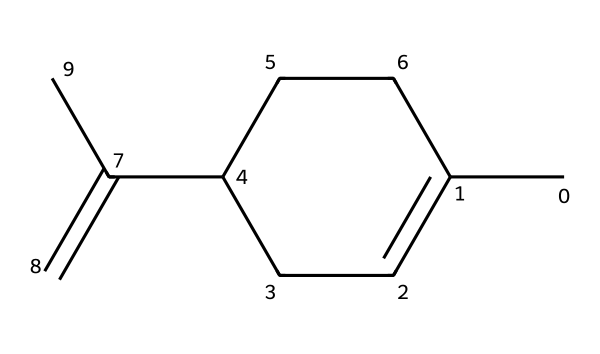What is the molecular formula of limonene? To find the molecular formula, identify the number of each type of atom in the structure. The molecule has 10 carbon atoms and 16 hydrogen atoms. Thus, the molecular formula is C10H16.
Answer: C10H16 How many double bonds are present in limonene? Inspect the structure for double bonds. Limonene has one double bond between the carbon atoms as indicated by the double lines in the structure.
Answer: 1 What type of hydrocarbon is limonene? Examine the structure to determine the type of hydrocarbon. Limonene contains a ring structure and at least one double bond, categorizing it as a monoterpene.
Answer: monoterpene What is the characteristic scent associated with limonene? Limonene is known for its aroma, particularly associated with citrus fruits. The structure implies that limonene has a strong citrus flavor.
Answer: citrus How does the cyclic structure of limonene affect its volatility? The cyclic structure of limonene gives it unique properties, including a lower boiling point compared to acyclic compounds, contributing to higher volatility. The ring structure allows for rapid evaporation.
Answer: higher volatility In terms of reactivity, what functional groups can limonene participate in? Analyze the structure for functional groups. Limonene, having a double bond, can undergo reactions typical for alkenes, such as electrophilic addition. There are no other functional groups present.
Answer: alkenes 